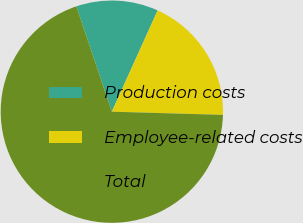Convert chart to OTSL. <chart><loc_0><loc_0><loc_500><loc_500><pie_chart><fcel>Production costs<fcel>Employee-related costs<fcel>Total<nl><fcel>11.94%<fcel>18.69%<fcel>69.37%<nl></chart> 